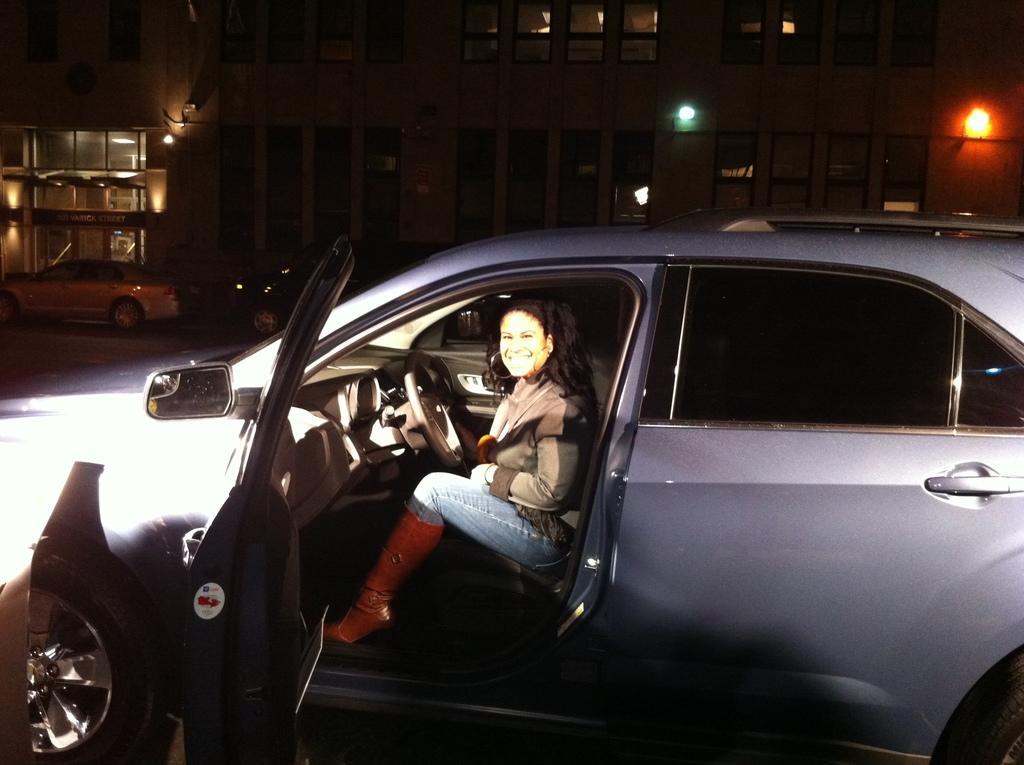How would you summarize this image in a sentence or two? This image is clicked on the roads. There is a car in blue color. In that car there is a woman sitting. In the background, there are buildings and cars. 